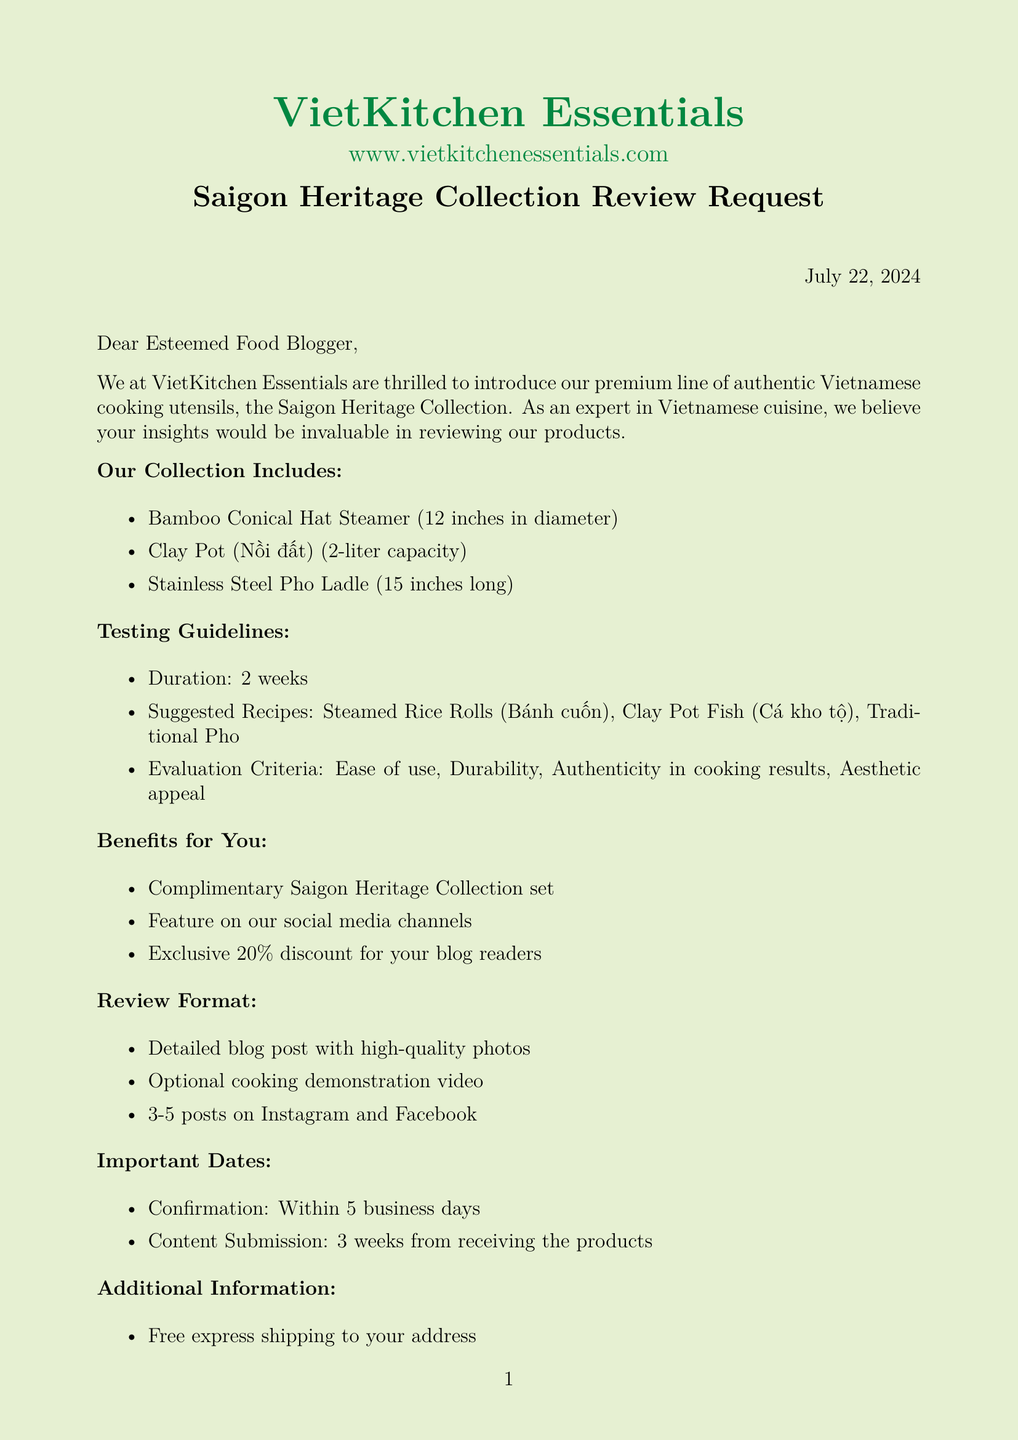What is the name of the company? The name of the company is provided in the document, which is VietKitchen Essentials.
Answer: VietKitchen Essentials Who is the contact person for the product review? The contact person's name is mentioned in the letter as Linh Nguyen.
Answer: Linh Nguyen What is the size of the Bamboo Conical Hat Steamer? The document specifies the size of the Bamboo Conical Hat Steamer as 12 inches in diameter.
Answer: 12 inches in diameter What is the evaluation criterion regarding ease? One of the evaluation criteria listed in the document concerns the ease of using the utensils.
Answer: Ease of use How many suggested recipes are provided in the testing guidelines? The document lists three suggested recipes for testing the utensils provided during the review.
Answer: 3 What is the compensation for the blogger? According to the document, the blogger will receive a complimentary set as compensation for the review.
Answer: Complimentary Saigon Heritage Collection set What is the submission deadline for the content? The document notes that the content submission deadline is three weeks from receiving the products.
Answer: 3 weeks What type of review format is required for the blog post? The document requires a detailed review with high-quality photos to be included in the blog post.
Answer: Detailed review with high-quality photos Is there a sustainability note mentioned? The letter includes a note stating that all packaging is eco-friendly and recyclable.
Answer: Eco-friendly and recyclable 